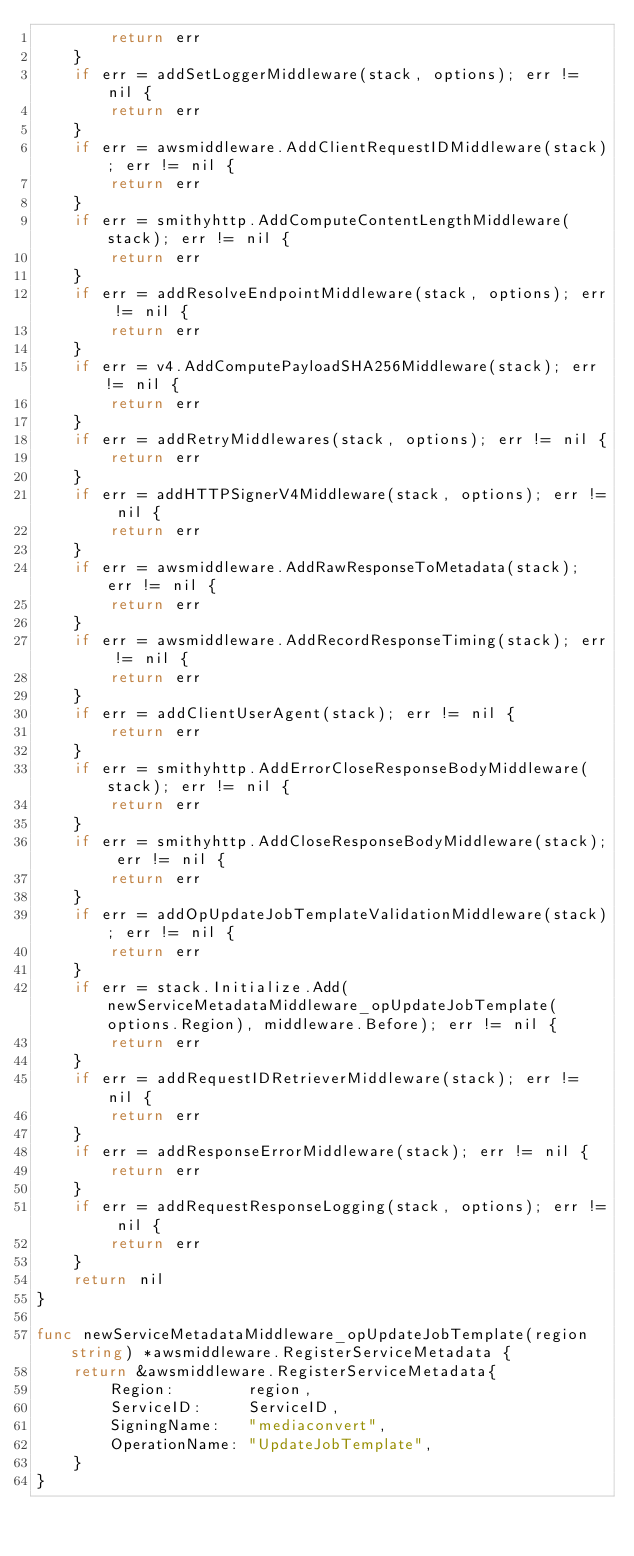<code> <loc_0><loc_0><loc_500><loc_500><_Go_>		return err
	}
	if err = addSetLoggerMiddleware(stack, options); err != nil {
		return err
	}
	if err = awsmiddleware.AddClientRequestIDMiddleware(stack); err != nil {
		return err
	}
	if err = smithyhttp.AddComputeContentLengthMiddleware(stack); err != nil {
		return err
	}
	if err = addResolveEndpointMiddleware(stack, options); err != nil {
		return err
	}
	if err = v4.AddComputePayloadSHA256Middleware(stack); err != nil {
		return err
	}
	if err = addRetryMiddlewares(stack, options); err != nil {
		return err
	}
	if err = addHTTPSignerV4Middleware(stack, options); err != nil {
		return err
	}
	if err = awsmiddleware.AddRawResponseToMetadata(stack); err != nil {
		return err
	}
	if err = awsmiddleware.AddRecordResponseTiming(stack); err != nil {
		return err
	}
	if err = addClientUserAgent(stack); err != nil {
		return err
	}
	if err = smithyhttp.AddErrorCloseResponseBodyMiddleware(stack); err != nil {
		return err
	}
	if err = smithyhttp.AddCloseResponseBodyMiddleware(stack); err != nil {
		return err
	}
	if err = addOpUpdateJobTemplateValidationMiddleware(stack); err != nil {
		return err
	}
	if err = stack.Initialize.Add(newServiceMetadataMiddleware_opUpdateJobTemplate(options.Region), middleware.Before); err != nil {
		return err
	}
	if err = addRequestIDRetrieverMiddleware(stack); err != nil {
		return err
	}
	if err = addResponseErrorMiddleware(stack); err != nil {
		return err
	}
	if err = addRequestResponseLogging(stack, options); err != nil {
		return err
	}
	return nil
}

func newServiceMetadataMiddleware_opUpdateJobTemplate(region string) *awsmiddleware.RegisterServiceMetadata {
	return &awsmiddleware.RegisterServiceMetadata{
		Region:        region,
		ServiceID:     ServiceID,
		SigningName:   "mediaconvert",
		OperationName: "UpdateJobTemplate",
	}
}
</code> 